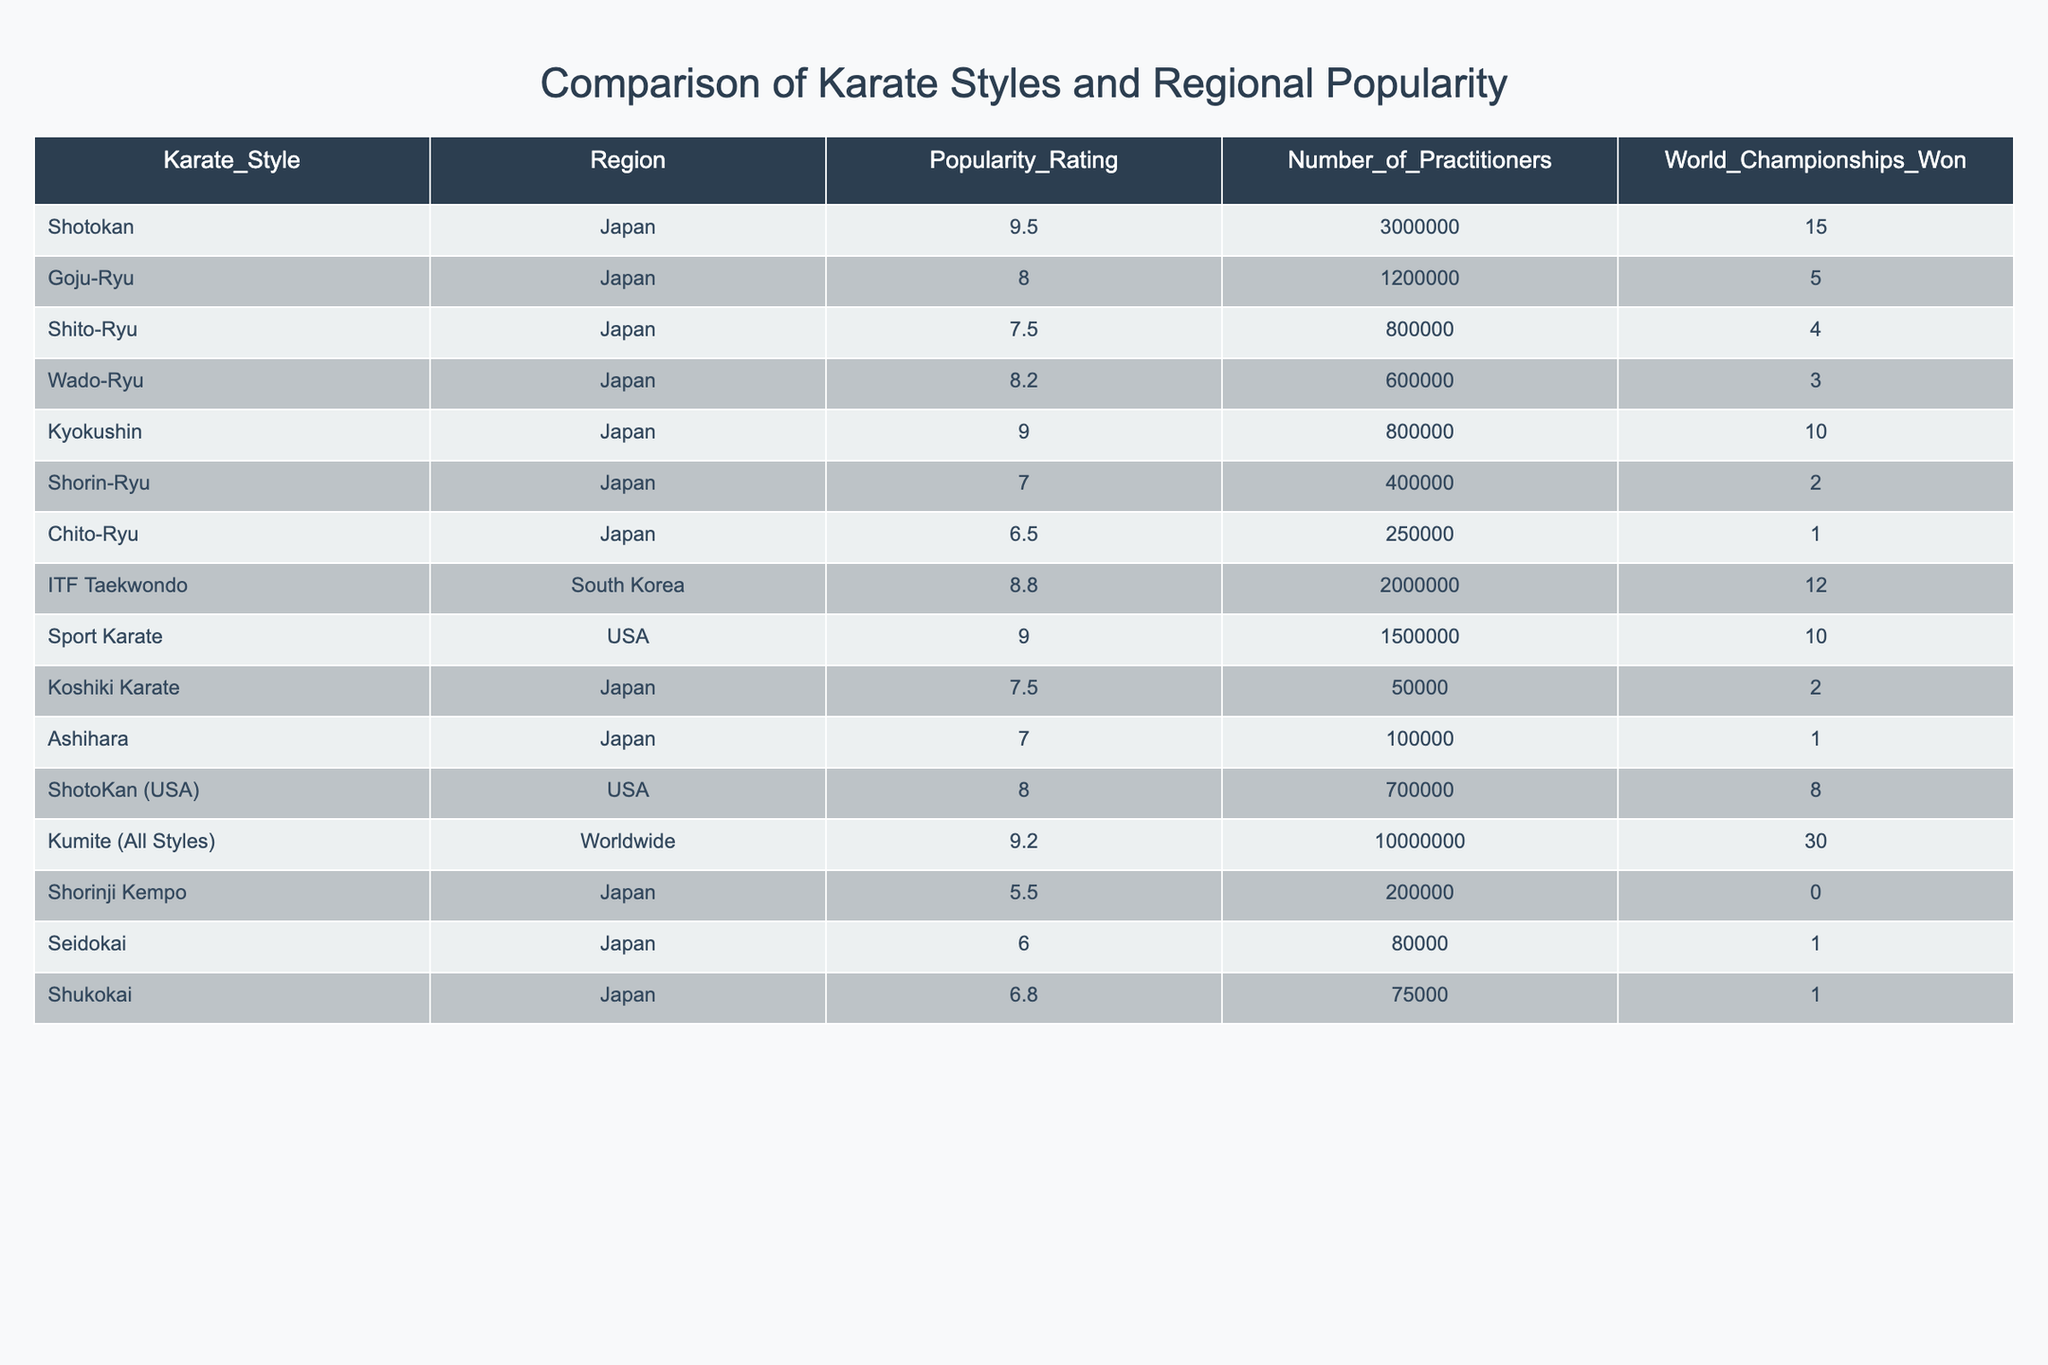What is the popularity rating of Shotokan karate? The popularity rating for Shotokan karate is listed directly in the table under the "Popularity_Rating" column, where it shows a value of 9.5.
Answer: 9.5 Which karate style has the highest number of practitioners? By examining the "Number_of_Practitioners" column, it is clear that Kumite (All Styles) has the highest value at 10,000,000 practitioners.
Answer: Kumite (All Styles) What is the average popularity rating of karate styles from Japan? To find the average, add the popularity ratings of the various styles from Japan: 9.5 + 8.0 + 7.5 + 8.2 + 9.0 + 7.0 + 6.5 + 7.5 + 7.0 + 6.8 = 78.0. There are 10 styles, so the average is 78.0 / 10 = 7.8.
Answer: 7.8 Is it true that Goju-Ryu has won more world championships than Shito-Ryu? By comparing the "World_Championships_Won" column, Goju-Ryu has won 5 championships, while Shito-Ryu has won 4, which means the statement is true.
Answer: Yes Which karate style has the lowest popularity rating and how many practitioners does it have? Looking through the "Popularity_Rating" column, Chito-Ryu has the lowest rating of 6.5, and the "Number_of_Practitioners" column shows it has 250,000 practitioners.
Answer: Chito-Ryu, 250000 If we consider the total number of world championships won by the styles in the USA, what is that total? Adding the "World_Championships_Won" for both ShotoKan (USA) and Sport Karate: 8 (ShotoKan) + 10 (Sport Karate) = 18 championships won in total.
Answer: 18 Which region has the most karate practitioners according to the table? By comparing the "Number_of_Practitioners" values for each region, Kumite (All Styles) is worldwide, reporting 10,000,000 practitioners, which is more than any other specific region.
Answer: Worldwide What is the difference in popularity rating between Kyokushin and Wado-Ryu karate? Subtract the popularity rating of Wado-Ryu (8.2) from that of Kyokushin (9.0): 9.0 - 8.2 = 0.8.
Answer: 0.8 Does Shorinji Kempo have a popularity rating of greater than 6.0? The table shows that Shorinji Kempo has a popularity rating of 5.5, which is less than 6.0, so the statement is false.
Answer: No 